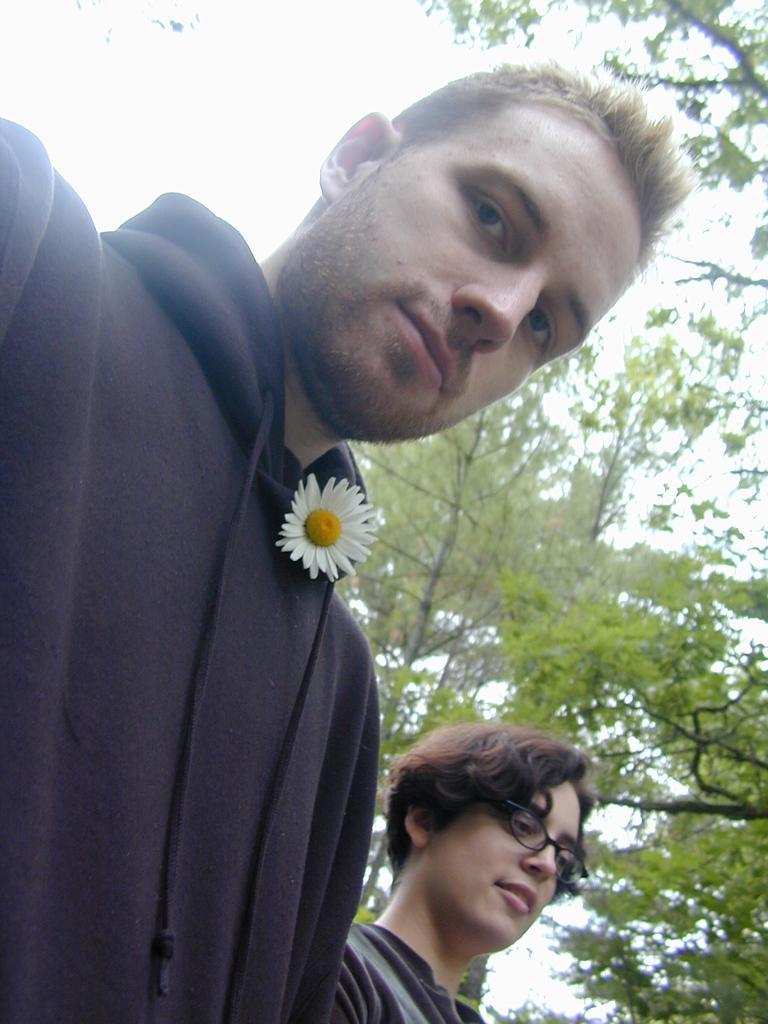Describe this image in one or two sentences. In this image we can see two persons. We can also see a flower kept on the jacket of the first person. On the backside we can see some branches of the trees and the sky. 